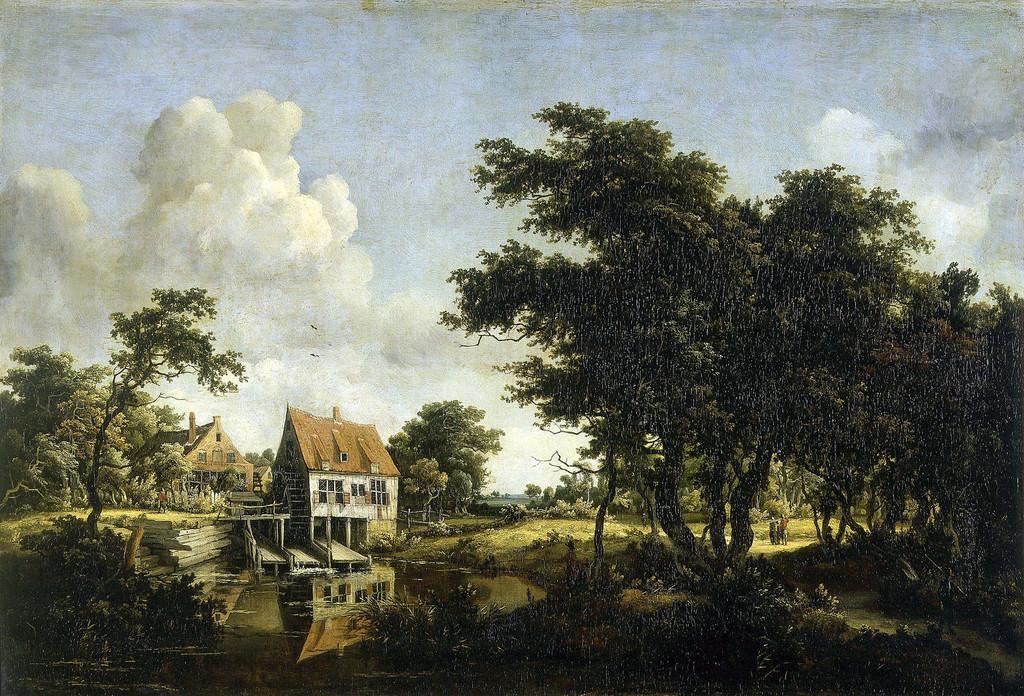Can you describe this image briefly? In the image we can see a painting. In the painting we can see some trees and houses and there are some clouds in the sky. At the bottom of the image there is water. 